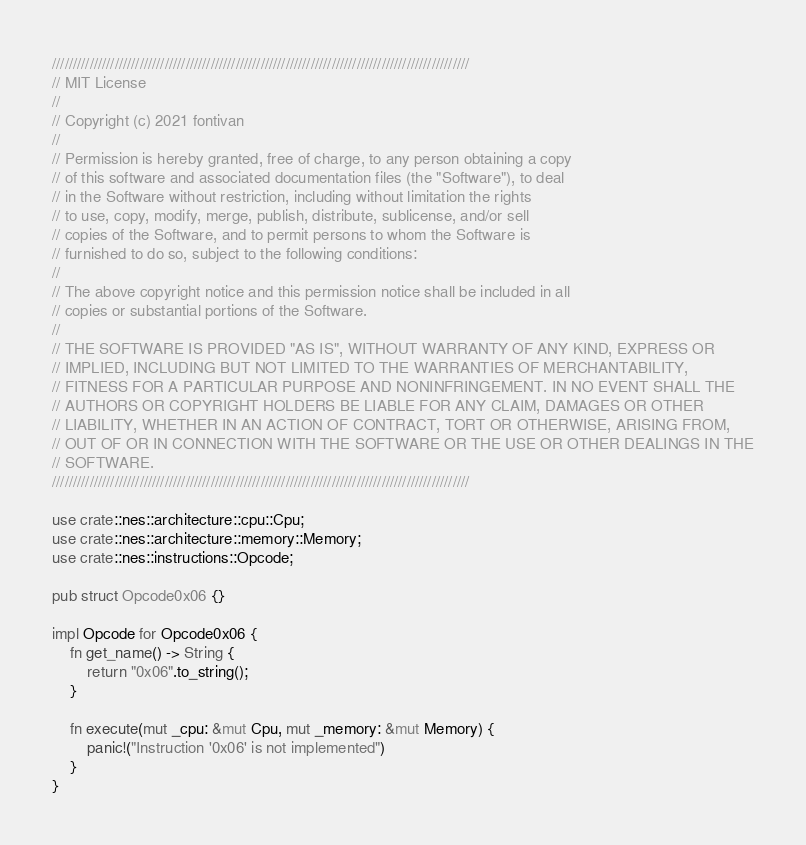<code> <loc_0><loc_0><loc_500><loc_500><_Rust_>////////////////////////////////////////////////////////////////////////////////////////////////////
// MIT License
//
// Copyright (c) 2021 fontivan
//
// Permission is hereby granted, free of charge, to any person obtaining a copy
// of this software and associated documentation files (the "Software"), to deal
// in the Software without restriction, including without limitation the rights
// to use, copy, modify, merge, publish, distribute, sublicense, and/or sell
// copies of the Software, and to permit persons to whom the Software is
// furnished to do so, subject to the following conditions:
//
// The above copyright notice and this permission notice shall be included in all
// copies or substantial portions of the Software.
//
// THE SOFTWARE IS PROVIDED "AS IS", WITHOUT WARRANTY OF ANY KIND, EXPRESS OR
// IMPLIED, INCLUDING BUT NOT LIMITED TO THE WARRANTIES OF MERCHANTABILITY,
// FITNESS FOR A PARTICULAR PURPOSE AND NONINFRINGEMENT. IN NO EVENT SHALL THE
// AUTHORS OR COPYRIGHT HOLDERS BE LIABLE FOR ANY CLAIM, DAMAGES OR OTHER
// LIABILITY, WHETHER IN AN ACTION OF CONTRACT, TORT OR OTHERWISE, ARISING FROM,
// OUT OF OR IN CONNECTION WITH THE SOFTWARE OR THE USE OR OTHER DEALINGS IN THE
// SOFTWARE.
////////////////////////////////////////////////////////////////////////////////////////////////////

use crate::nes::architecture::cpu::Cpu;
use crate::nes::architecture::memory::Memory;
use crate::nes::instructions::Opcode;

pub struct Opcode0x06 {}

impl Opcode for Opcode0x06 {
    fn get_name() -> String {
        return "0x06".to_string();
    }

    fn execute(mut _cpu: &mut Cpu, mut _memory: &mut Memory) {
        panic!("Instruction '0x06' is not implemented")
    }
}
</code> 